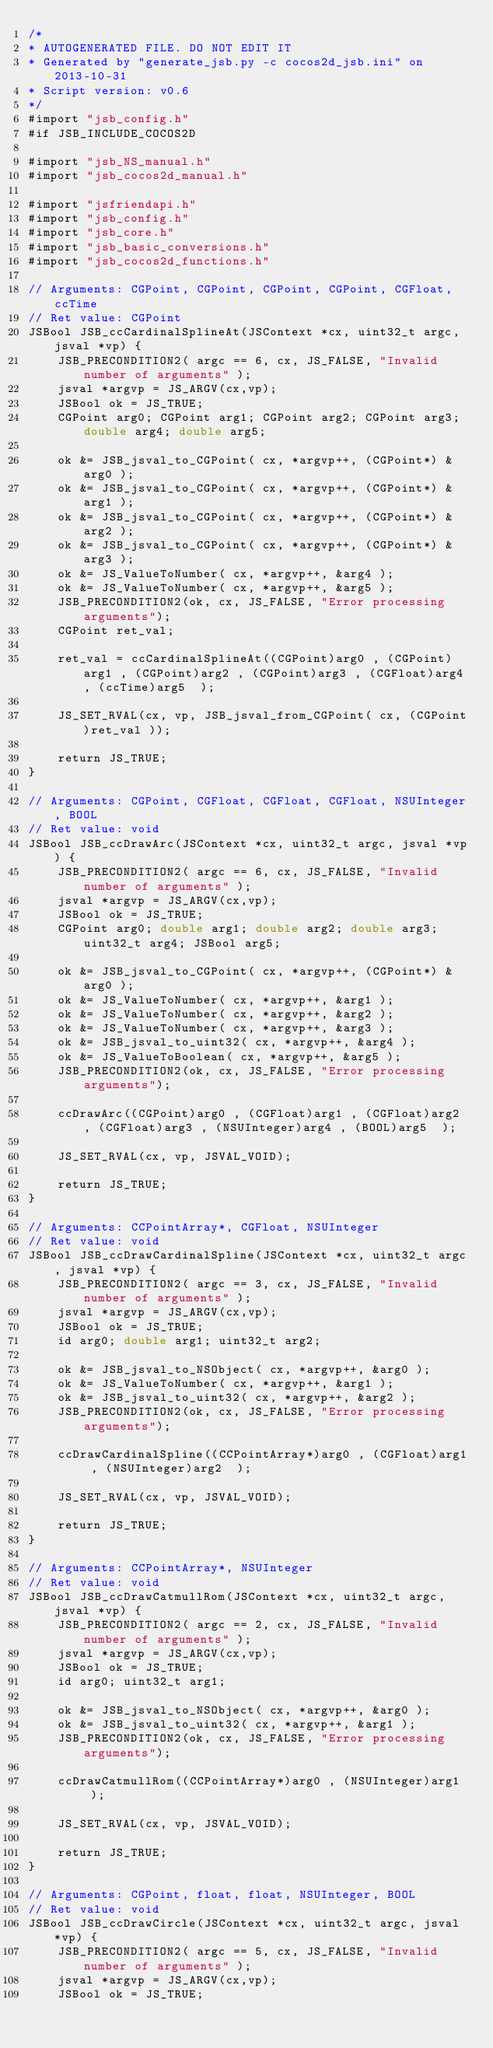Convert code to text. <code><loc_0><loc_0><loc_500><loc_500><_ObjectiveC_>/*
* AUTOGENERATED FILE. DO NOT EDIT IT
* Generated by "generate_jsb.py -c cocos2d_jsb.ini" on 2013-10-31
* Script version: v0.6
*/
#import "jsb_config.h"
#if JSB_INCLUDE_COCOS2D

#import "jsb_NS_manual.h"
#import "jsb_cocos2d_manual.h"

#import "jsfriendapi.h"
#import "jsb_config.h"
#import "jsb_core.h"
#import "jsb_basic_conversions.h"
#import "jsb_cocos2d_functions.h"

// Arguments: CGPoint, CGPoint, CGPoint, CGPoint, CGFloat, ccTime
// Ret value: CGPoint
JSBool JSB_ccCardinalSplineAt(JSContext *cx, uint32_t argc, jsval *vp) {
	JSB_PRECONDITION2( argc == 6, cx, JS_FALSE, "Invalid number of arguments" );
	jsval *argvp = JS_ARGV(cx,vp);
	JSBool ok = JS_TRUE;
	CGPoint arg0; CGPoint arg1; CGPoint arg2; CGPoint arg3; double arg4; double arg5; 

	ok &= JSB_jsval_to_CGPoint( cx, *argvp++, (CGPoint*) &arg0 );
	ok &= JSB_jsval_to_CGPoint( cx, *argvp++, (CGPoint*) &arg1 );
	ok &= JSB_jsval_to_CGPoint( cx, *argvp++, (CGPoint*) &arg2 );
	ok &= JSB_jsval_to_CGPoint( cx, *argvp++, (CGPoint*) &arg3 );
	ok &= JS_ValueToNumber( cx, *argvp++, &arg4 );
	ok &= JS_ValueToNumber( cx, *argvp++, &arg5 );
	JSB_PRECONDITION2(ok, cx, JS_FALSE, "Error processing arguments");
	CGPoint ret_val;

	ret_val = ccCardinalSplineAt((CGPoint)arg0 , (CGPoint)arg1 , (CGPoint)arg2 , (CGPoint)arg3 , (CGFloat)arg4 , (ccTime)arg5  );

	JS_SET_RVAL(cx, vp, JSB_jsval_from_CGPoint( cx, (CGPoint)ret_val ));

	return JS_TRUE;
}

// Arguments: CGPoint, CGFloat, CGFloat, CGFloat, NSUInteger, BOOL
// Ret value: void
JSBool JSB_ccDrawArc(JSContext *cx, uint32_t argc, jsval *vp) {
	JSB_PRECONDITION2( argc == 6, cx, JS_FALSE, "Invalid number of arguments" );
	jsval *argvp = JS_ARGV(cx,vp);
	JSBool ok = JS_TRUE;
	CGPoint arg0; double arg1; double arg2; double arg3; uint32_t arg4; JSBool arg5; 

	ok &= JSB_jsval_to_CGPoint( cx, *argvp++, (CGPoint*) &arg0 );
	ok &= JS_ValueToNumber( cx, *argvp++, &arg1 );
	ok &= JS_ValueToNumber( cx, *argvp++, &arg2 );
	ok &= JS_ValueToNumber( cx, *argvp++, &arg3 );
	ok &= JSB_jsval_to_uint32( cx, *argvp++, &arg4 );
	ok &= JS_ValueToBoolean( cx, *argvp++, &arg5 );
	JSB_PRECONDITION2(ok, cx, JS_FALSE, "Error processing arguments");

	ccDrawArc((CGPoint)arg0 , (CGFloat)arg1 , (CGFloat)arg2 , (CGFloat)arg3 , (NSUInteger)arg4 , (BOOL)arg5  );

	JS_SET_RVAL(cx, vp, JSVAL_VOID);

	return JS_TRUE;
}

// Arguments: CCPointArray*, CGFloat, NSUInteger
// Ret value: void
JSBool JSB_ccDrawCardinalSpline(JSContext *cx, uint32_t argc, jsval *vp) {
	JSB_PRECONDITION2( argc == 3, cx, JS_FALSE, "Invalid number of arguments" );
	jsval *argvp = JS_ARGV(cx,vp);
	JSBool ok = JS_TRUE;
	id arg0; double arg1; uint32_t arg2; 

	ok &= JSB_jsval_to_NSObject( cx, *argvp++, &arg0 );
	ok &= JS_ValueToNumber( cx, *argvp++, &arg1 );
	ok &= JSB_jsval_to_uint32( cx, *argvp++, &arg2 );
	JSB_PRECONDITION2(ok, cx, JS_FALSE, "Error processing arguments");

	ccDrawCardinalSpline((CCPointArray*)arg0 , (CGFloat)arg1 , (NSUInteger)arg2  );

	JS_SET_RVAL(cx, vp, JSVAL_VOID);

	return JS_TRUE;
}

// Arguments: CCPointArray*, NSUInteger
// Ret value: void
JSBool JSB_ccDrawCatmullRom(JSContext *cx, uint32_t argc, jsval *vp) {
	JSB_PRECONDITION2( argc == 2, cx, JS_FALSE, "Invalid number of arguments" );
	jsval *argvp = JS_ARGV(cx,vp);
	JSBool ok = JS_TRUE;
	id arg0; uint32_t arg1; 

	ok &= JSB_jsval_to_NSObject( cx, *argvp++, &arg0 );
	ok &= JSB_jsval_to_uint32( cx, *argvp++, &arg1 );
	JSB_PRECONDITION2(ok, cx, JS_FALSE, "Error processing arguments");

	ccDrawCatmullRom((CCPointArray*)arg0 , (NSUInteger)arg1  );

	JS_SET_RVAL(cx, vp, JSVAL_VOID);

	return JS_TRUE;
}

// Arguments: CGPoint, float, float, NSUInteger, BOOL
// Ret value: void
JSBool JSB_ccDrawCircle(JSContext *cx, uint32_t argc, jsval *vp) {
	JSB_PRECONDITION2( argc == 5, cx, JS_FALSE, "Invalid number of arguments" );
	jsval *argvp = JS_ARGV(cx,vp);
	JSBool ok = JS_TRUE;</code> 